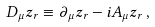Convert formula to latex. <formula><loc_0><loc_0><loc_500><loc_500>D _ { \mu } z _ { r } \equiv \partial _ { \mu } z _ { r } - i A _ { \mu } z _ { r } \, ,</formula> 